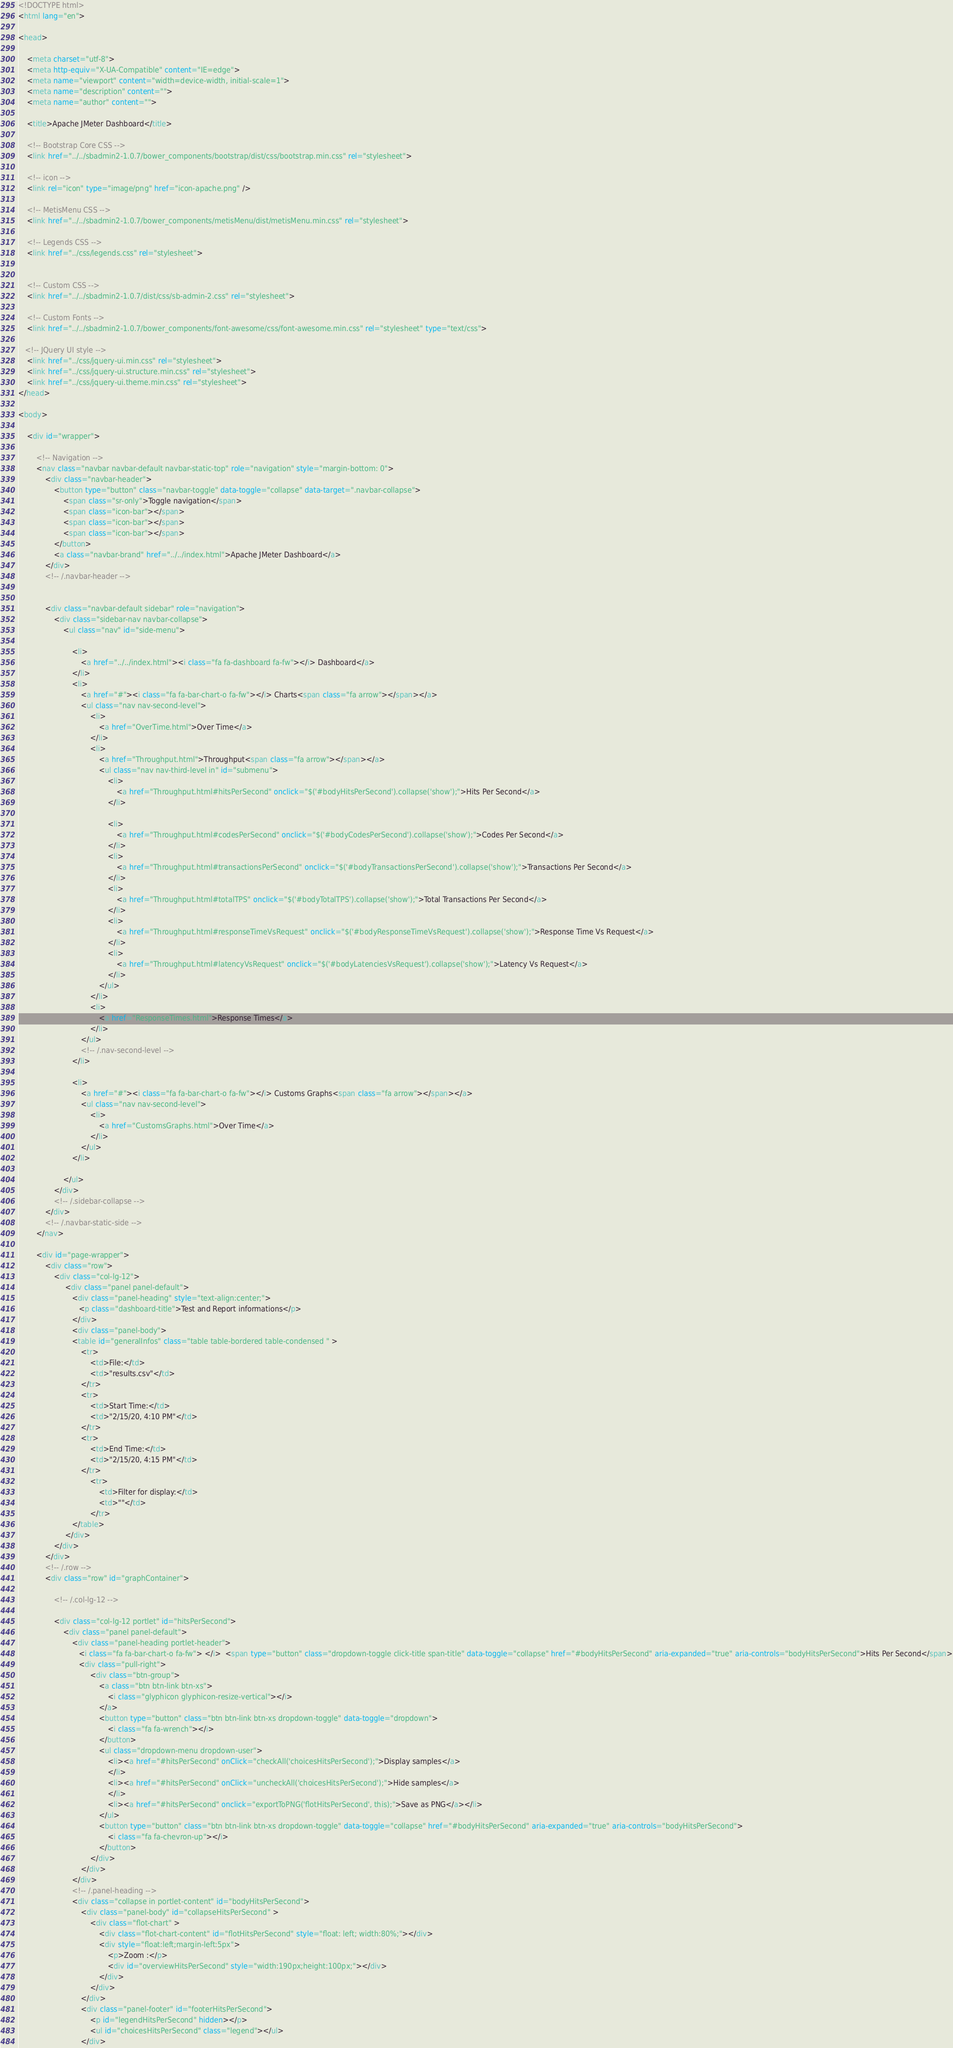<code> <loc_0><loc_0><loc_500><loc_500><_HTML_><!DOCTYPE html>
<html lang="en">

<head>

    <meta charset="utf-8">
    <meta http-equiv="X-UA-Compatible" content="IE=edge">
    <meta name="viewport" content="width=device-width, initial-scale=1">
    <meta name="description" content="">
    <meta name="author" content="">

    <title>Apache JMeter Dashboard</title>

    <!-- Bootstrap Core CSS -->
    <link href="../../sbadmin2-1.0.7/bower_components/bootstrap/dist/css/bootstrap.min.css" rel="stylesheet">

    <!-- icon -->
    <link rel="icon" type="image/png" href="icon-apache.png" />

    <!-- MetisMenu CSS -->
    <link href="../../sbadmin2-1.0.7/bower_components/metisMenu/dist/metisMenu.min.css" rel="stylesheet">

    <!-- Legends CSS -->
    <link href="../css/legends.css" rel="stylesheet">


    <!-- Custom CSS -->
    <link href="../../sbadmin2-1.0.7/dist/css/sb-admin-2.css" rel="stylesheet">

    <!-- Custom Fonts -->
    <link href="../../sbadmin2-1.0.7/bower_components/font-awesome/css/font-awesome.min.css" rel="stylesheet" type="text/css">

   <!-- JQuery UI style -->
    <link href="../css/jquery-ui.min.css" rel="stylesheet">
    <link href="../css/jquery-ui.structure.min.css" rel="stylesheet">
    <link href="../css/jquery-ui.theme.min.css" rel="stylesheet">
</head>

<body>

    <div id="wrapper">

        <!-- Navigation -->
        <nav class="navbar navbar-default navbar-static-top" role="navigation" style="margin-bottom: 0">
            <div class="navbar-header">
                <button type="button" class="navbar-toggle" data-toggle="collapse" data-target=".navbar-collapse">
                    <span class="sr-only">Toggle navigation</span>
                    <span class="icon-bar"></span>
                    <span class="icon-bar"></span>
                    <span class="icon-bar"></span>
                </button>
                <a class="navbar-brand" href="../../index.html">Apache JMeter Dashboard</a>
            </div>
            <!-- /.navbar-header -->


            <div class="navbar-default sidebar" role="navigation">
                <div class="sidebar-nav navbar-collapse">
                    <ul class="nav" id="side-menu">

                        <li>
                            <a href="../../index.html"><i class="fa fa-dashboard fa-fw"></i> Dashboard</a>
                        </li>
                        <li>
                            <a href="#"><i class="fa fa-bar-chart-o fa-fw"></i> Charts<span class="fa arrow"></span></a>
                            <ul class="nav nav-second-level">
                                <li>
                                    <a href="OverTime.html">Over Time</a>
                                </li>
                                <li>
                                    <a href="Throughput.html">Throughput<span class="fa arrow"></span></a>
                                    <ul class="nav nav-third-level in" id="submenu">
                                        <li>
                                            <a href="Throughput.html#hitsPerSecond" onclick="$('#bodyHitsPerSecond').collapse('show');">Hits Per Second</a>
                                        </li>

                                        <li>
                                            <a href="Throughput.html#codesPerSecond" onclick="$('#bodyCodesPerSecond').collapse('show');">Codes Per Second</a>
                                        </li>
                                        <li>
                                            <a href="Throughput.html#transactionsPerSecond" onclick="$('#bodyTransactionsPerSecond').collapse('show');">Transactions Per Second</a>
                                        </li>
                                        <li>
                                            <a href="Throughput.html#totalTPS" onclick="$('#bodyTotalTPS').collapse('show');">Total Transactions Per Second</a>
                                        </li>
                                        <li>
                                            <a href="Throughput.html#responseTimeVsRequest" onclick="$('#bodyResponseTimeVsRequest').collapse('show');">Response Time Vs Request</a>
                                        </li>
                                        <li>
                                            <a href="Throughput.html#latencyVsRequest" onclick="$('#bodyLatenciesVsRequest').collapse('show');">Latency Vs Request</a>
                                        </li>
                                    </ul>
                                </li>
                                <li>
                                    <a href="ResponseTimes.html">Response Times</a>
                                </li>
                            </ul>
                            <!-- /.nav-second-level -->
                        </li>

                        <li>
                            <a href="#"><i class="fa fa-bar-chart-o fa-fw"></i> Customs Graphs<span class="fa arrow"></span></a>
                            <ul class="nav nav-second-level">
                                <li>
                                    <a href="CustomsGraphs.html">Over Time</a>
                                </li>
                            </ul>
                        </li>

                    </ul>
                </div>
                <!-- /.sidebar-collapse -->
            </div>
            <!-- /.navbar-static-side -->
        </nav>

        <div id="page-wrapper">
            <div class="row">
                <div class="col-lg-12">
                     <div class="panel panel-default">
                        <div class="panel-heading" style="text-align:center;">
                           <p class="dashboard-title">Test and Report informations</p>
                        </div>
                        <div class="panel-body">
                        <table id="generalInfos" class="table table-bordered table-condensed " >
                            <tr>
                                <td>File:</td>
                                <td>"results.csv"</td>
                            </tr>
                            <tr>
                                <td>Start Time:</td>
                                <td>"2/15/20, 4:10 PM"</td>
                            </tr>
                            <tr>
                                <td>End Time:</td>
                                <td>"2/15/20, 4:15 PM"</td>
                            </tr>
                                <tr>
                                    <td>Filter for display:</td>
                                    <td>""</td>
                                </tr>
                        </table>
                     </div>
                </div>
            </div>
            <!-- /.row -->
            <div class="row" id="graphContainer">

                <!-- /.col-lg-12 -->

                <div class="col-lg-12 portlet" id="hitsPerSecond">
                    <div class="panel panel-default">
                        <div class="panel-heading portlet-header">
                           <i class="fa fa-bar-chart-o fa-fw"> </i>  <span type="button" class="dropdown-toggle click-title span-title" data-toggle="collapse" href="#bodyHitsPerSecond" aria-expanded="true" aria-controls="bodyHitsPerSecond">Hits Per Second</span>
                           <div class="pull-right">
                                <div class="btn-group">
                                    <a class="btn btn-link btn-xs">
                                        <i class="glyphicon glyphicon-resize-vertical"></i>
                                    </a>
                                    <button type="button" class="btn btn-link btn-xs dropdown-toggle" data-toggle="dropdown">
                                        <i class="fa fa-wrench"></i>
                                    </button>
                                    <ul class="dropdown-menu dropdown-user">
                                        <li><a href="#hitsPerSecond" onClick="checkAll('choicesHitsPerSecond');">Display samples</a>
                                        </li>
                                        <li><a href="#hitsPerSecond" onClick="uncheckAll('choicesHitsPerSecond');">Hide samples</a>
                                        </li>
                                        <li><a href="#hitsPerSecond" onclick="exportToPNG('flotHitsPerSecond', this);">Save as PNG</a></li>
                                    </ul>
                                    <button type="button" class="btn btn-link btn-xs dropdown-toggle" data-toggle="collapse" href="#bodyHitsPerSecond" aria-expanded="true" aria-controls="bodyHitsPerSecond">
                                        <i class="fa fa-chevron-up"></i>
                                    </button>
                                </div>
                            </div>
                        </div>
                        <!-- /.panel-heading -->
                        <div class="collapse in portlet-content" id="bodyHitsPerSecond">
                            <div class="panel-body" id="collapseHitsPerSecond" >
                                <div class="flot-chart" >
                                    <div class="flot-chart-content" id="flotHitsPerSecond" style="float: left; width:80%;"></div>
                                    <div style="float:left;margin-left:5px">
                                        <p>Zoom :</p>
                                        <div id="overviewHitsPerSecond" style="width:190px;height:100px;"></div>
                                    </div>
                                </div>
                            </div>
                            <div class="panel-footer" id="footerHitsPerSecond">
                                <p id="legendHitsPerSecond" hidden></p>
                                <ul id="choicesHitsPerSecond" class="legend"></ul>
                            </div></code> 